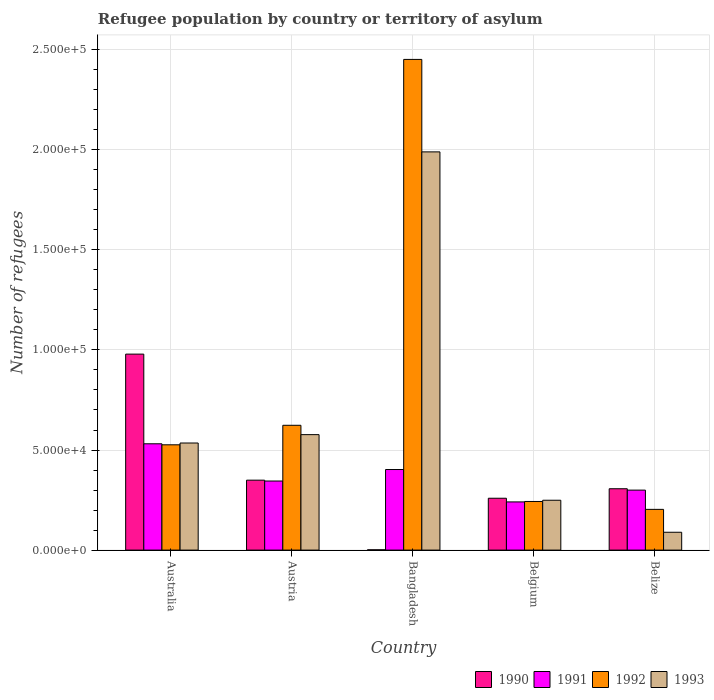How many groups of bars are there?
Give a very brief answer. 5. Are the number of bars per tick equal to the number of legend labels?
Offer a terse response. Yes. What is the label of the 5th group of bars from the left?
Make the answer very short. Belize. In how many cases, is the number of bars for a given country not equal to the number of legend labels?
Provide a succinct answer. 0. What is the number of refugees in 1990 in Bangladesh?
Offer a terse response. 145. Across all countries, what is the maximum number of refugees in 1990?
Make the answer very short. 9.79e+04. Across all countries, what is the minimum number of refugees in 1993?
Offer a very short reply. 8912. In which country was the number of refugees in 1992 minimum?
Offer a terse response. Belize. What is the total number of refugees in 1993 in the graph?
Your answer should be compact. 3.44e+05. What is the difference between the number of refugees in 1993 in Austria and that in Belgium?
Your answer should be very brief. 3.28e+04. What is the difference between the number of refugees in 1991 in Belize and the number of refugees in 1993 in Austria?
Provide a short and direct response. -2.77e+04. What is the average number of refugees in 1991 per country?
Give a very brief answer. 3.64e+04. What is the difference between the number of refugees of/in 1990 and number of refugees of/in 1991 in Bangladesh?
Offer a very short reply. -4.01e+04. What is the ratio of the number of refugees in 1991 in Austria to that in Belgium?
Give a very brief answer. 1.43. Is the number of refugees in 1992 in Austria less than that in Bangladesh?
Your answer should be compact. Yes. What is the difference between the highest and the second highest number of refugees in 1991?
Your answer should be very brief. -5752. What is the difference between the highest and the lowest number of refugees in 1992?
Offer a terse response. 2.25e+05. In how many countries, is the number of refugees in 1992 greater than the average number of refugees in 1992 taken over all countries?
Ensure brevity in your answer.  1. Is the sum of the number of refugees in 1990 in Belgium and Belize greater than the maximum number of refugees in 1993 across all countries?
Your answer should be very brief. No. What does the 1st bar from the left in Australia represents?
Your answer should be very brief. 1990. What does the 3rd bar from the right in Australia represents?
Give a very brief answer. 1991. Is it the case that in every country, the sum of the number of refugees in 1992 and number of refugees in 1993 is greater than the number of refugees in 1990?
Keep it short and to the point. No. Are all the bars in the graph horizontal?
Offer a terse response. No. What is the difference between two consecutive major ticks on the Y-axis?
Offer a very short reply. 5.00e+04. Are the values on the major ticks of Y-axis written in scientific E-notation?
Your answer should be compact. Yes. Does the graph contain any zero values?
Give a very brief answer. No. How are the legend labels stacked?
Offer a terse response. Horizontal. What is the title of the graph?
Offer a terse response. Refugee population by country or territory of asylum. Does "1998" appear as one of the legend labels in the graph?
Provide a short and direct response. No. What is the label or title of the Y-axis?
Ensure brevity in your answer.  Number of refugees. What is the Number of refugees of 1990 in Australia?
Offer a terse response. 9.79e+04. What is the Number of refugees of 1991 in Australia?
Provide a short and direct response. 5.31e+04. What is the Number of refugees in 1992 in Australia?
Offer a very short reply. 5.26e+04. What is the Number of refugees of 1993 in Australia?
Your answer should be compact. 5.35e+04. What is the Number of refugees in 1990 in Austria?
Make the answer very short. 3.49e+04. What is the Number of refugees in 1991 in Austria?
Provide a succinct answer. 3.45e+04. What is the Number of refugees in 1992 in Austria?
Provide a short and direct response. 6.24e+04. What is the Number of refugees of 1993 in Austria?
Provide a short and direct response. 5.77e+04. What is the Number of refugees of 1990 in Bangladesh?
Keep it short and to the point. 145. What is the Number of refugees of 1991 in Bangladesh?
Provide a succinct answer. 4.03e+04. What is the Number of refugees of 1992 in Bangladesh?
Provide a short and direct response. 2.45e+05. What is the Number of refugees in 1993 in Bangladesh?
Provide a short and direct response. 1.99e+05. What is the Number of refugees of 1990 in Belgium?
Provide a succinct answer. 2.59e+04. What is the Number of refugees of 1991 in Belgium?
Offer a terse response. 2.41e+04. What is the Number of refugees in 1992 in Belgium?
Give a very brief answer. 2.43e+04. What is the Number of refugees in 1993 in Belgium?
Make the answer very short. 2.49e+04. What is the Number of refugees in 1990 in Belize?
Make the answer very short. 3.07e+04. What is the Number of refugees of 1991 in Belize?
Your answer should be very brief. 3.00e+04. What is the Number of refugees in 1992 in Belize?
Provide a short and direct response. 2.04e+04. What is the Number of refugees of 1993 in Belize?
Give a very brief answer. 8912. Across all countries, what is the maximum Number of refugees of 1990?
Provide a short and direct response. 9.79e+04. Across all countries, what is the maximum Number of refugees in 1991?
Keep it short and to the point. 5.31e+04. Across all countries, what is the maximum Number of refugees of 1992?
Make the answer very short. 2.45e+05. Across all countries, what is the maximum Number of refugees in 1993?
Your response must be concise. 1.99e+05. Across all countries, what is the minimum Number of refugees in 1990?
Ensure brevity in your answer.  145. Across all countries, what is the minimum Number of refugees in 1991?
Provide a succinct answer. 2.41e+04. Across all countries, what is the minimum Number of refugees of 1992?
Offer a very short reply. 2.04e+04. Across all countries, what is the minimum Number of refugees of 1993?
Offer a terse response. 8912. What is the total Number of refugees in 1990 in the graph?
Keep it short and to the point. 1.90e+05. What is the total Number of refugees in 1991 in the graph?
Ensure brevity in your answer.  1.82e+05. What is the total Number of refugees in 1992 in the graph?
Offer a very short reply. 4.05e+05. What is the total Number of refugees of 1993 in the graph?
Keep it short and to the point. 3.44e+05. What is the difference between the Number of refugees of 1990 in Australia and that in Austria?
Make the answer very short. 6.30e+04. What is the difference between the Number of refugees in 1991 in Australia and that in Austria?
Offer a very short reply. 1.86e+04. What is the difference between the Number of refugees in 1992 in Australia and that in Austria?
Provide a short and direct response. -9751. What is the difference between the Number of refugees in 1993 in Australia and that in Austria?
Your response must be concise. -4182. What is the difference between the Number of refugees of 1990 in Australia and that in Bangladesh?
Offer a very short reply. 9.78e+04. What is the difference between the Number of refugees of 1991 in Australia and that in Bangladesh?
Your answer should be very brief. 1.29e+04. What is the difference between the Number of refugees of 1992 in Australia and that in Bangladesh?
Ensure brevity in your answer.  -1.93e+05. What is the difference between the Number of refugees of 1993 in Australia and that in Bangladesh?
Offer a terse response. -1.45e+05. What is the difference between the Number of refugees of 1990 in Australia and that in Belgium?
Give a very brief answer. 7.20e+04. What is the difference between the Number of refugees of 1991 in Australia and that in Belgium?
Your answer should be very brief. 2.90e+04. What is the difference between the Number of refugees in 1992 in Australia and that in Belgium?
Provide a succinct answer. 2.83e+04. What is the difference between the Number of refugees in 1993 in Australia and that in Belgium?
Offer a very short reply. 2.86e+04. What is the difference between the Number of refugees in 1990 in Australia and that in Belize?
Your answer should be compact. 6.73e+04. What is the difference between the Number of refugees in 1991 in Australia and that in Belize?
Provide a succinct answer. 2.31e+04. What is the difference between the Number of refugees in 1992 in Australia and that in Belize?
Your answer should be compact. 3.23e+04. What is the difference between the Number of refugees in 1993 in Australia and that in Belize?
Your answer should be very brief. 4.46e+04. What is the difference between the Number of refugees of 1990 in Austria and that in Bangladesh?
Offer a very short reply. 3.48e+04. What is the difference between the Number of refugees of 1991 in Austria and that in Bangladesh?
Offer a terse response. -5752. What is the difference between the Number of refugees in 1992 in Austria and that in Bangladesh?
Make the answer very short. -1.83e+05. What is the difference between the Number of refugees of 1993 in Austria and that in Bangladesh?
Keep it short and to the point. -1.41e+05. What is the difference between the Number of refugees in 1990 in Austria and that in Belgium?
Offer a very short reply. 9027. What is the difference between the Number of refugees of 1991 in Austria and that in Belgium?
Keep it short and to the point. 1.04e+04. What is the difference between the Number of refugees in 1992 in Austria and that in Belgium?
Provide a short and direct response. 3.81e+04. What is the difference between the Number of refugees of 1993 in Austria and that in Belgium?
Provide a succinct answer. 3.28e+04. What is the difference between the Number of refugees in 1990 in Austria and that in Belize?
Keep it short and to the point. 4281. What is the difference between the Number of refugees in 1991 in Austria and that in Belize?
Your response must be concise. 4539. What is the difference between the Number of refugees of 1992 in Austria and that in Belize?
Keep it short and to the point. 4.20e+04. What is the difference between the Number of refugees in 1993 in Austria and that in Belize?
Ensure brevity in your answer.  4.88e+04. What is the difference between the Number of refugees of 1990 in Bangladesh and that in Belgium?
Provide a succinct answer. -2.58e+04. What is the difference between the Number of refugees of 1991 in Bangladesh and that in Belgium?
Give a very brief answer. 1.62e+04. What is the difference between the Number of refugees in 1992 in Bangladesh and that in Belgium?
Your response must be concise. 2.21e+05. What is the difference between the Number of refugees of 1993 in Bangladesh and that in Belgium?
Offer a very short reply. 1.74e+05. What is the difference between the Number of refugees of 1990 in Bangladesh and that in Belize?
Provide a succinct answer. -3.05e+04. What is the difference between the Number of refugees in 1991 in Bangladesh and that in Belize?
Give a very brief answer. 1.03e+04. What is the difference between the Number of refugees in 1992 in Bangladesh and that in Belize?
Your answer should be very brief. 2.25e+05. What is the difference between the Number of refugees of 1993 in Bangladesh and that in Belize?
Keep it short and to the point. 1.90e+05. What is the difference between the Number of refugees in 1990 in Belgium and that in Belize?
Ensure brevity in your answer.  -4746. What is the difference between the Number of refugees in 1991 in Belgium and that in Belize?
Offer a very short reply. -5898. What is the difference between the Number of refugees of 1992 in Belgium and that in Belize?
Give a very brief answer. 3941. What is the difference between the Number of refugees in 1993 in Belgium and that in Belize?
Give a very brief answer. 1.60e+04. What is the difference between the Number of refugees of 1990 in Australia and the Number of refugees of 1991 in Austria?
Ensure brevity in your answer.  6.34e+04. What is the difference between the Number of refugees in 1990 in Australia and the Number of refugees in 1992 in Austria?
Make the answer very short. 3.56e+04. What is the difference between the Number of refugees in 1990 in Australia and the Number of refugees in 1993 in Austria?
Provide a short and direct response. 4.02e+04. What is the difference between the Number of refugees of 1991 in Australia and the Number of refugees of 1992 in Austria?
Offer a terse response. -9238. What is the difference between the Number of refugees of 1991 in Australia and the Number of refugees of 1993 in Austria?
Keep it short and to the point. -4570. What is the difference between the Number of refugees of 1992 in Australia and the Number of refugees of 1993 in Austria?
Ensure brevity in your answer.  -5083. What is the difference between the Number of refugees of 1990 in Australia and the Number of refugees of 1991 in Bangladesh?
Your answer should be very brief. 5.77e+04. What is the difference between the Number of refugees of 1990 in Australia and the Number of refugees of 1992 in Bangladesh?
Your answer should be very brief. -1.47e+05. What is the difference between the Number of refugees of 1990 in Australia and the Number of refugees of 1993 in Bangladesh?
Offer a very short reply. -1.01e+05. What is the difference between the Number of refugees of 1991 in Australia and the Number of refugees of 1992 in Bangladesh?
Your response must be concise. -1.92e+05. What is the difference between the Number of refugees in 1991 in Australia and the Number of refugees in 1993 in Bangladesh?
Your answer should be very brief. -1.46e+05. What is the difference between the Number of refugees of 1992 in Australia and the Number of refugees of 1993 in Bangladesh?
Your answer should be very brief. -1.46e+05. What is the difference between the Number of refugees in 1990 in Australia and the Number of refugees in 1991 in Belgium?
Your response must be concise. 7.38e+04. What is the difference between the Number of refugees of 1990 in Australia and the Number of refugees of 1992 in Belgium?
Make the answer very short. 7.36e+04. What is the difference between the Number of refugees in 1990 in Australia and the Number of refugees in 1993 in Belgium?
Keep it short and to the point. 7.30e+04. What is the difference between the Number of refugees in 1991 in Australia and the Number of refugees in 1992 in Belgium?
Offer a very short reply. 2.88e+04. What is the difference between the Number of refugees of 1991 in Australia and the Number of refugees of 1993 in Belgium?
Your answer should be compact. 2.82e+04. What is the difference between the Number of refugees of 1992 in Australia and the Number of refugees of 1993 in Belgium?
Ensure brevity in your answer.  2.77e+04. What is the difference between the Number of refugees of 1990 in Australia and the Number of refugees of 1991 in Belize?
Provide a short and direct response. 6.79e+04. What is the difference between the Number of refugees of 1990 in Australia and the Number of refugees of 1992 in Belize?
Your response must be concise. 7.76e+04. What is the difference between the Number of refugees in 1990 in Australia and the Number of refugees in 1993 in Belize?
Keep it short and to the point. 8.90e+04. What is the difference between the Number of refugees in 1991 in Australia and the Number of refugees in 1992 in Belize?
Provide a succinct answer. 3.28e+04. What is the difference between the Number of refugees in 1991 in Australia and the Number of refugees in 1993 in Belize?
Ensure brevity in your answer.  4.42e+04. What is the difference between the Number of refugees in 1992 in Australia and the Number of refugees in 1993 in Belize?
Offer a terse response. 4.37e+04. What is the difference between the Number of refugees of 1990 in Austria and the Number of refugees of 1991 in Bangladesh?
Ensure brevity in your answer.  -5322. What is the difference between the Number of refugees in 1990 in Austria and the Number of refugees in 1992 in Bangladesh?
Make the answer very short. -2.10e+05. What is the difference between the Number of refugees in 1990 in Austria and the Number of refugees in 1993 in Bangladesh?
Make the answer very short. -1.64e+05. What is the difference between the Number of refugees of 1991 in Austria and the Number of refugees of 1992 in Bangladesh?
Make the answer very short. -2.11e+05. What is the difference between the Number of refugees of 1991 in Austria and the Number of refugees of 1993 in Bangladesh?
Give a very brief answer. -1.64e+05. What is the difference between the Number of refugees in 1992 in Austria and the Number of refugees in 1993 in Bangladesh?
Make the answer very short. -1.37e+05. What is the difference between the Number of refugees in 1990 in Austria and the Number of refugees in 1991 in Belgium?
Your response must be concise. 1.09e+04. What is the difference between the Number of refugees in 1990 in Austria and the Number of refugees in 1992 in Belgium?
Offer a terse response. 1.06e+04. What is the difference between the Number of refugees of 1990 in Austria and the Number of refugees of 1993 in Belgium?
Your response must be concise. 1.00e+04. What is the difference between the Number of refugees in 1991 in Austria and the Number of refugees in 1992 in Belgium?
Offer a terse response. 1.02e+04. What is the difference between the Number of refugees of 1991 in Austria and the Number of refugees of 1993 in Belgium?
Keep it short and to the point. 9600. What is the difference between the Number of refugees of 1992 in Austria and the Number of refugees of 1993 in Belgium?
Provide a short and direct response. 3.74e+04. What is the difference between the Number of refugees of 1990 in Austria and the Number of refugees of 1991 in Belize?
Offer a very short reply. 4969. What is the difference between the Number of refugees of 1990 in Austria and the Number of refugees of 1992 in Belize?
Your response must be concise. 1.46e+04. What is the difference between the Number of refugees in 1990 in Austria and the Number of refugees in 1993 in Belize?
Keep it short and to the point. 2.60e+04. What is the difference between the Number of refugees in 1991 in Austria and the Number of refugees in 1992 in Belize?
Offer a terse response. 1.42e+04. What is the difference between the Number of refugees in 1991 in Austria and the Number of refugees in 1993 in Belize?
Give a very brief answer. 2.56e+04. What is the difference between the Number of refugees in 1992 in Austria and the Number of refugees in 1993 in Belize?
Your response must be concise. 5.34e+04. What is the difference between the Number of refugees in 1990 in Bangladesh and the Number of refugees in 1991 in Belgium?
Make the answer very short. -2.39e+04. What is the difference between the Number of refugees in 1990 in Bangladesh and the Number of refugees in 1992 in Belgium?
Your response must be concise. -2.41e+04. What is the difference between the Number of refugees in 1990 in Bangladesh and the Number of refugees in 1993 in Belgium?
Your answer should be compact. -2.48e+04. What is the difference between the Number of refugees in 1991 in Bangladesh and the Number of refugees in 1992 in Belgium?
Offer a terse response. 1.60e+04. What is the difference between the Number of refugees of 1991 in Bangladesh and the Number of refugees of 1993 in Belgium?
Keep it short and to the point. 1.54e+04. What is the difference between the Number of refugees of 1992 in Bangladesh and the Number of refugees of 1993 in Belgium?
Your response must be concise. 2.20e+05. What is the difference between the Number of refugees of 1990 in Bangladesh and the Number of refugees of 1991 in Belize?
Keep it short and to the point. -2.98e+04. What is the difference between the Number of refugees in 1990 in Bangladesh and the Number of refugees in 1992 in Belize?
Offer a terse response. -2.02e+04. What is the difference between the Number of refugees of 1990 in Bangladesh and the Number of refugees of 1993 in Belize?
Your answer should be compact. -8767. What is the difference between the Number of refugees of 1991 in Bangladesh and the Number of refugees of 1992 in Belize?
Provide a short and direct response. 1.99e+04. What is the difference between the Number of refugees of 1991 in Bangladesh and the Number of refugees of 1993 in Belize?
Provide a succinct answer. 3.13e+04. What is the difference between the Number of refugees in 1992 in Bangladesh and the Number of refugees in 1993 in Belize?
Make the answer very short. 2.36e+05. What is the difference between the Number of refugees in 1990 in Belgium and the Number of refugees in 1991 in Belize?
Keep it short and to the point. -4058. What is the difference between the Number of refugees of 1990 in Belgium and the Number of refugees of 1992 in Belize?
Provide a short and direct response. 5560. What is the difference between the Number of refugees in 1990 in Belgium and the Number of refugees in 1993 in Belize?
Make the answer very short. 1.70e+04. What is the difference between the Number of refugees of 1991 in Belgium and the Number of refugees of 1992 in Belize?
Keep it short and to the point. 3720. What is the difference between the Number of refugees in 1991 in Belgium and the Number of refugees in 1993 in Belize?
Give a very brief answer. 1.52e+04. What is the difference between the Number of refugees in 1992 in Belgium and the Number of refugees in 1993 in Belize?
Ensure brevity in your answer.  1.54e+04. What is the average Number of refugees of 1990 per country?
Provide a short and direct response. 3.79e+04. What is the average Number of refugees in 1991 per country?
Provide a short and direct response. 3.64e+04. What is the average Number of refugees in 1992 per country?
Your response must be concise. 8.10e+04. What is the average Number of refugees in 1993 per country?
Give a very brief answer. 6.88e+04. What is the difference between the Number of refugees in 1990 and Number of refugees in 1991 in Australia?
Your answer should be compact. 4.48e+04. What is the difference between the Number of refugees of 1990 and Number of refugees of 1992 in Australia?
Ensure brevity in your answer.  4.53e+04. What is the difference between the Number of refugees in 1990 and Number of refugees in 1993 in Australia?
Provide a short and direct response. 4.44e+04. What is the difference between the Number of refugees of 1991 and Number of refugees of 1992 in Australia?
Offer a very short reply. 513. What is the difference between the Number of refugees of 1991 and Number of refugees of 1993 in Australia?
Offer a terse response. -388. What is the difference between the Number of refugees of 1992 and Number of refugees of 1993 in Australia?
Your answer should be compact. -901. What is the difference between the Number of refugees of 1990 and Number of refugees of 1991 in Austria?
Give a very brief answer. 430. What is the difference between the Number of refugees in 1990 and Number of refugees in 1992 in Austria?
Provide a succinct answer. -2.74e+04. What is the difference between the Number of refugees of 1990 and Number of refugees of 1993 in Austria?
Provide a succinct answer. -2.27e+04. What is the difference between the Number of refugees of 1991 and Number of refugees of 1992 in Austria?
Your response must be concise. -2.78e+04. What is the difference between the Number of refugees of 1991 and Number of refugees of 1993 in Austria?
Your answer should be compact. -2.32e+04. What is the difference between the Number of refugees of 1992 and Number of refugees of 1993 in Austria?
Your answer should be compact. 4668. What is the difference between the Number of refugees in 1990 and Number of refugees in 1991 in Bangladesh?
Ensure brevity in your answer.  -4.01e+04. What is the difference between the Number of refugees of 1990 and Number of refugees of 1992 in Bangladesh?
Give a very brief answer. -2.45e+05. What is the difference between the Number of refugees of 1990 and Number of refugees of 1993 in Bangladesh?
Offer a terse response. -1.99e+05. What is the difference between the Number of refugees in 1991 and Number of refugees in 1992 in Bangladesh?
Offer a terse response. -2.05e+05. What is the difference between the Number of refugees in 1991 and Number of refugees in 1993 in Bangladesh?
Offer a very short reply. -1.59e+05. What is the difference between the Number of refugees in 1992 and Number of refugees in 1993 in Bangladesh?
Keep it short and to the point. 4.62e+04. What is the difference between the Number of refugees of 1990 and Number of refugees of 1991 in Belgium?
Make the answer very short. 1840. What is the difference between the Number of refugees of 1990 and Number of refugees of 1992 in Belgium?
Give a very brief answer. 1619. What is the difference between the Number of refugees in 1990 and Number of refugees in 1993 in Belgium?
Offer a very short reply. 1003. What is the difference between the Number of refugees of 1991 and Number of refugees of 1992 in Belgium?
Keep it short and to the point. -221. What is the difference between the Number of refugees in 1991 and Number of refugees in 1993 in Belgium?
Give a very brief answer. -837. What is the difference between the Number of refugees of 1992 and Number of refugees of 1993 in Belgium?
Ensure brevity in your answer.  -616. What is the difference between the Number of refugees in 1990 and Number of refugees in 1991 in Belize?
Ensure brevity in your answer.  688. What is the difference between the Number of refugees in 1990 and Number of refugees in 1992 in Belize?
Make the answer very short. 1.03e+04. What is the difference between the Number of refugees in 1990 and Number of refugees in 1993 in Belize?
Keep it short and to the point. 2.17e+04. What is the difference between the Number of refugees in 1991 and Number of refugees in 1992 in Belize?
Your answer should be very brief. 9618. What is the difference between the Number of refugees in 1991 and Number of refugees in 1993 in Belize?
Make the answer very short. 2.11e+04. What is the difference between the Number of refugees in 1992 and Number of refugees in 1993 in Belize?
Offer a terse response. 1.14e+04. What is the ratio of the Number of refugees of 1990 in Australia to that in Austria?
Make the answer very short. 2.8. What is the ratio of the Number of refugees of 1991 in Australia to that in Austria?
Your answer should be compact. 1.54. What is the ratio of the Number of refugees in 1992 in Australia to that in Austria?
Your answer should be very brief. 0.84. What is the ratio of the Number of refugees in 1993 in Australia to that in Austria?
Your answer should be compact. 0.93. What is the ratio of the Number of refugees of 1990 in Australia to that in Bangladesh?
Give a very brief answer. 675.28. What is the ratio of the Number of refugees in 1991 in Australia to that in Bangladesh?
Ensure brevity in your answer.  1.32. What is the ratio of the Number of refugees in 1992 in Australia to that in Bangladesh?
Provide a succinct answer. 0.21. What is the ratio of the Number of refugees of 1993 in Australia to that in Bangladesh?
Offer a very short reply. 0.27. What is the ratio of the Number of refugees in 1990 in Australia to that in Belgium?
Your answer should be very brief. 3.78. What is the ratio of the Number of refugees in 1991 in Australia to that in Belgium?
Keep it short and to the point. 2.21. What is the ratio of the Number of refugees of 1992 in Australia to that in Belgium?
Offer a terse response. 2.17. What is the ratio of the Number of refugees in 1993 in Australia to that in Belgium?
Ensure brevity in your answer.  2.15. What is the ratio of the Number of refugees of 1990 in Australia to that in Belize?
Make the answer very short. 3.19. What is the ratio of the Number of refugees in 1991 in Australia to that in Belize?
Ensure brevity in your answer.  1.77. What is the ratio of the Number of refugees of 1992 in Australia to that in Belize?
Offer a terse response. 2.58. What is the ratio of the Number of refugees in 1993 in Australia to that in Belize?
Offer a very short reply. 6. What is the ratio of the Number of refugees in 1990 in Austria to that in Bangladesh?
Ensure brevity in your answer.  240.95. What is the ratio of the Number of refugees of 1991 in Austria to that in Bangladesh?
Offer a very short reply. 0.86. What is the ratio of the Number of refugees of 1992 in Austria to that in Bangladesh?
Your response must be concise. 0.25. What is the ratio of the Number of refugees of 1993 in Austria to that in Bangladesh?
Provide a succinct answer. 0.29. What is the ratio of the Number of refugees of 1990 in Austria to that in Belgium?
Your answer should be very brief. 1.35. What is the ratio of the Number of refugees in 1991 in Austria to that in Belgium?
Offer a very short reply. 1.43. What is the ratio of the Number of refugees of 1992 in Austria to that in Belgium?
Your answer should be compact. 2.57. What is the ratio of the Number of refugees of 1993 in Austria to that in Belgium?
Your answer should be very brief. 2.32. What is the ratio of the Number of refugees in 1990 in Austria to that in Belize?
Offer a terse response. 1.14. What is the ratio of the Number of refugees of 1991 in Austria to that in Belize?
Your response must be concise. 1.15. What is the ratio of the Number of refugees in 1992 in Austria to that in Belize?
Your answer should be very brief. 3.06. What is the ratio of the Number of refugees of 1993 in Austria to that in Belize?
Your answer should be very brief. 6.47. What is the ratio of the Number of refugees in 1990 in Bangladesh to that in Belgium?
Your response must be concise. 0.01. What is the ratio of the Number of refugees in 1991 in Bangladesh to that in Belgium?
Give a very brief answer. 1.67. What is the ratio of the Number of refugees of 1992 in Bangladesh to that in Belgium?
Keep it short and to the point. 10.09. What is the ratio of the Number of refugees in 1993 in Bangladesh to that in Belgium?
Your answer should be compact. 7.99. What is the ratio of the Number of refugees of 1990 in Bangladesh to that in Belize?
Your answer should be compact. 0. What is the ratio of the Number of refugees in 1991 in Bangladesh to that in Belize?
Ensure brevity in your answer.  1.34. What is the ratio of the Number of refugees of 1992 in Bangladesh to that in Belize?
Give a very brief answer. 12.05. What is the ratio of the Number of refugees of 1993 in Bangladesh to that in Belize?
Your answer should be compact. 22.32. What is the ratio of the Number of refugees in 1990 in Belgium to that in Belize?
Your answer should be very brief. 0.85. What is the ratio of the Number of refugees of 1991 in Belgium to that in Belize?
Make the answer very short. 0.8. What is the ratio of the Number of refugees of 1992 in Belgium to that in Belize?
Give a very brief answer. 1.19. What is the ratio of the Number of refugees of 1993 in Belgium to that in Belize?
Give a very brief answer. 2.79. What is the difference between the highest and the second highest Number of refugees in 1990?
Your response must be concise. 6.30e+04. What is the difference between the highest and the second highest Number of refugees in 1991?
Provide a short and direct response. 1.29e+04. What is the difference between the highest and the second highest Number of refugees of 1992?
Ensure brevity in your answer.  1.83e+05. What is the difference between the highest and the second highest Number of refugees in 1993?
Your answer should be compact. 1.41e+05. What is the difference between the highest and the lowest Number of refugees of 1990?
Offer a terse response. 9.78e+04. What is the difference between the highest and the lowest Number of refugees of 1991?
Provide a succinct answer. 2.90e+04. What is the difference between the highest and the lowest Number of refugees in 1992?
Offer a terse response. 2.25e+05. What is the difference between the highest and the lowest Number of refugees in 1993?
Your answer should be very brief. 1.90e+05. 